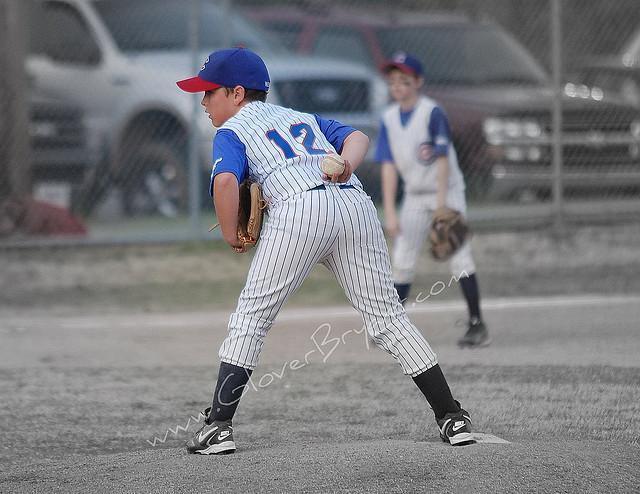How many cars can you see?
Give a very brief answer. 4. How many people are there?
Give a very brief answer. 2. 